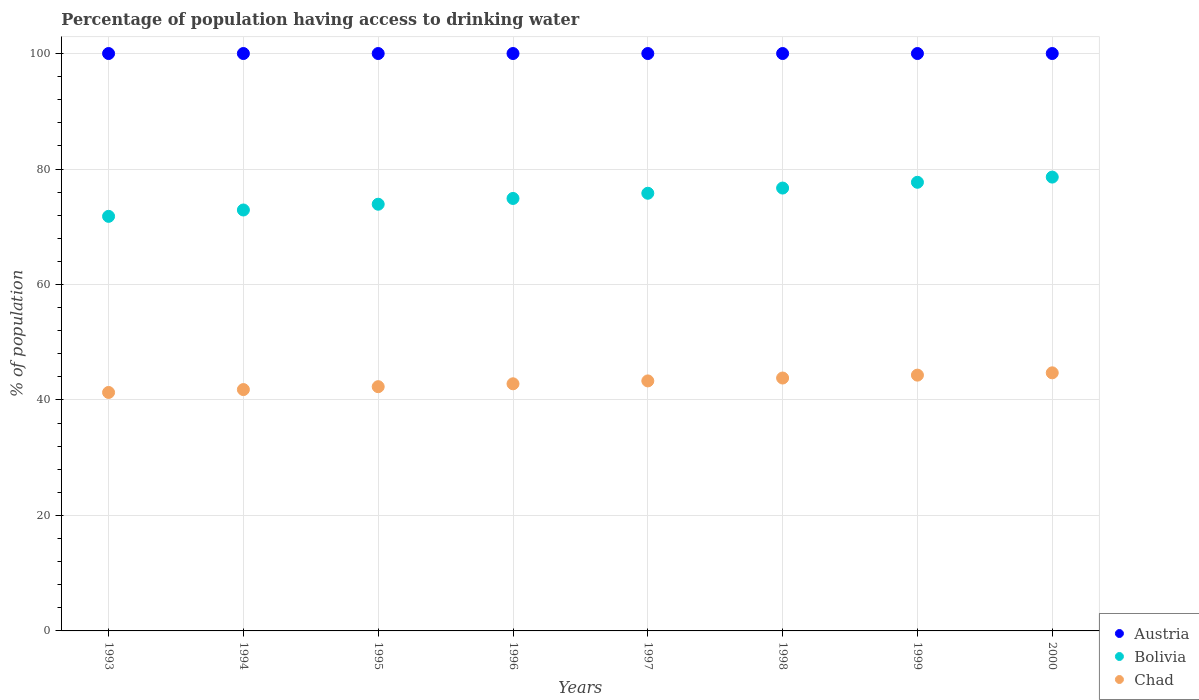How many different coloured dotlines are there?
Ensure brevity in your answer.  3. Is the number of dotlines equal to the number of legend labels?
Offer a very short reply. Yes. What is the percentage of population having access to drinking water in Chad in 1997?
Provide a succinct answer. 43.3. Across all years, what is the maximum percentage of population having access to drinking water in Austria?
Offer a very short reply. 100. Across all years, what is the minimum percentage of population having access to drinking water in Austria?
Make the answer very short. 100. What is the total percentage of population having access to drinking water in Austria in the graph?
Provide a succinct answer. 800. What is the difference between the percentage of population having access to drinking water in Chad in 1997 and that in 2000?
Your answer should be compact. -1.4. What is the difference between the percentage of population having access to drinking water in Bolivia in 1999 and the percentage of population having access to drinking water in Chad in 1996?
Your answer should be very brief. 34.9. What is the average percentage of population having access to drinking water in Bolivia per year?
Your answer should be very brief. 75.29. In the year 1998, what is the difference between the percentage of population having access to drinking water in Austria and percentage of population having access to drinking water in Chad?
Provide a succinct answer. 56.2. In how many years, is the percentage of population having access to drinking water in Chad greater than 96 %?
Keep it short and to the point. 0. What is the ratio of the percentage of population having access to drinking water in Austria in 1995 to that in 1998?
Your response must be concise. 1. What is the difference between the highest and the second highest percentage of population having access to drinking water in Austria?
Ensure brevity in your answer.  0. What is the difference between the highest and the lowest percentage of population having access to drinking water in Bolivia?
Provide a succinct answer. 6.8. In how many years, is the percentage of population having access to drinking water in Austria greater than the average percentage of population having access to drinking water in Austria taken over all years?
Make the answer very short. 0. Is it the case that in every year, the sum of the percentage of population having access to drinking water in Austria and percentage of population having access to drinking water in Chad  is greater than the percentage of population having access to drinking water in Bolivia?
Your answer should be very brief. Yes. Does the percentage of population having access to drinking water in Bolivia monotonically increase over the years?
Offer a terse response. Yes. Is the percentage of population having access to drinking water in Chad strictly less than the percentage of population having access to drinking water in Austria over the years?
Your answer should be very brief. Yes. Are the values on the major ticks of Y-axis written in scientific E-notation?
Offer a terse response. No. Does the graph contain any zero values?
Your answer should be very brief. No. Does the graph contain grids?
Give a very brief answer. Yes. Where does the legend appear in the graph?
Your response must be concise. Bottom right. What is the title of the graph?
Offer a very short reply. Percentage of population having access to drinking water. What is the label or title of the X-axis?
Ensure brevity in your answer.  Years. What is the label or title of the Y-axis?
Give a very brief answer. % of population. What is the % of population of Bolivia in 1993?
Offer a very short reply. 71.8. What is the % of population of Chad in 1993?
Offer a very short reply. 41.3. What is the % of population in Bolivia in 1994?
Ensure brevity in your answer.  72.9. What is the % of population in Chad in 1994?
Provide a succinct answer. 41.8. What is the % of population in Austria in 1995?
Your response must be concise. 100. What is the % of population in Bolivia in 1995?
Ensure brevity in your answer.  73.9. What is the % of population in Chad in 1995?
Your answer should be compact. 42.3. What is the % of population of Austria in 1996?
Keep it short and to the point. 100. What is the % of population of Bolivia in 1996?
Your response must be concise. 74.9. What is the % of population of Chad in 1996?
Keep it short and to the point. 42.8. What is the % of population of Austria in 1997?
Provide a succinct answer. 100. What is the % of population of Bolivia in 1997?
Provide a short and direct response. 75.8. What is the % of population in Chad in 1997?
Your answer should be very brief. 43.3. What is the % of population of Austria in 1998?
Make the answer very short. 100. What is the % of population of Bolivia in 1998?
Offer a very short reply. 76.7. What is the % of population of Chad in 1998?
Keep it short and to the point. 43.8. What is the % of population in Bolivia in 1999?
Keep it short and to the point. 77.7. What is the % of population in Chad in 1999?
Offer a very short reply. 44.3. What is the % of population in Bolivia in 2000?
Ensure brevity in your answer.  78.6. What is the % of population in Chad in 2000?
Provide a succinct answer. 44.7. Across all years, what is the maximum % of population in Austria?
Your answer should be compact. 100. Across all years, what is the maximum % of population of Bolivia?
Provide a short and direct response. 78.6. Across all years, what is the maximum % of population of Chad?
Provide a short and direct response. 44.7. Across all years, what is the minimum % of population of Bolivia?
Your response must be concise. 71.8. Across all years, what is the minimum % of population in Chad?
Provide a short and direct response. 41.3. What is the total % of population in Austria in the graph?
Provide a short and direct response. 800. What is the total % of population in Bolivia in the graph?
Ensure brevity in your answer.  602.3. What is the total % of population in Chad in the graph?
Provide a succinct answer. 344.3. What is the difference between the % of population of Bolivia in 1993 and that in 1994?
Ensure brevity in your answer.  -1.1. What is the difference between the % of population of Chad in 1993 and that in 1994?
Keep it short and to the point. -0.5. What is the difference between the % of population in Chad in 1993 and that in 1995?
Keep it short and to the point. -1. What is the difference between the % of population in Austria in 1993 and that in 1996?
Keep it short and to the point. 0. What is the difference between the % of population of Bolivia in 1993 and that in 1996?
Provide a short and direct response. -3.1. What is the difference between the % of population in Chad in 1993 and that in 1996?
Offer a very short reply. -1.5. What is the difference between the % of population in Chad in 1993 and that in 1997?
Make the answer very short. -2. What is the difference between the % of population in Austria in 1993 and that in 1999?
Offer a terse response. 0. What is the difference between the % of population in Bolivia in 1993 and that in 1999?
Your answer should be compact. -5.9. What is the difference between the % of population of Austria in 1993 and that in 2000?
Ensure brevity in your answer.  0. What is the difference between the % of population of Bolivia in 1993 and that in 2000?
Ensure brevity in your answer.  -6.8. What is the difference between the % of population in Chad in 1993 and that in 2000?
Provide a short and direct response. -3.4. What is the difference between the % of population of Austria in 1994 and that in 1995?
Your response must be concise. 0. What is the difference between the % of population of Bolivia in 1994 and that in 1995?
Ensure brevity in your answer.  -1. What is the difference between the % of population in Chad in 1994 and that in 1995?
Your response must be concise. -0.5. What is the difference between the % of population in Austria in 1994 and that in 1996?
Your answer should be compact. 0. What is the difference between the % of population in Chad in 1994 and that in 1996?
Ensure brevity in your answer.  -1. What is the difference between the % of population of Bolivia in 1994 and that in 1997?
Offer a terse response. -2.9. What is the difference between the % of population in Austria in 1994 and that in 1998?
Offer a terse response. 0. What is the difference between the % of population in Bolivia in 1994 and that in 1998?
Give a very brief answer. -3.8. What is the difference between the % of population in Chad in 1994 and that in 1998?
Your answer should be very brief. -2. What is the difference between the % of population of Austria in 1994 and that in 1999?
Your answer should be compact. 0. What is the difference between the % of population in Chad in 1994 and that in 1999?
Your response must be concise. -2.5. What is the difference between the % of population of Austria in 1994 and that in 2000?
Provide a short and direct response. 0. What is the difference between the % of population in Chad in 1995 and that in 1997?
Your response must be concise. -1. What is the difference between the % of population of Austria in 1995 and that in 1998?
Ensure brevity in your answer.  0. What is the difference between the % of population in Bolivia in 1995 and that in 1998?
Keep it short and to the point. -2.8. What is the difference between the % of population in Austria in 1995 and that in 1999?
Offer a very short reply. 0. What is the difference between the % of population in Bolivia in 1995 and that in 1999?
Ensure brevity in your answer.  -3.8. What is the difference between the % of population of Chad in 1995 and that in 1999?
Provide a succinct answer. -2. What is the difference between the % of population of Bolivia in 1995 and that in 2000?
Your answer should be compact. -4.7. What is the difference between the % of population in Chad in 1996 and that in 1997?
Your answer should be compact. -0.5. What is the difference between the % of population of Austria in 1996 and that in 1998?
Your answer should be compact. 0. What is the difference between the % of population in Bolivia in 1996 and that in 1998?
Give a very brief answer. -1.8. What is the difference between the % of population in Bolivia in 1996 and that in 2000?
Give a very brief answer. -3.7. What is the difference between the % of population of Chad in 1996 and that in 2000?
Offer a terse response. -1.9. What is the difference between the % of population in Bolivia in 1997 and that in 1998?
Keep it short and to the point. -0.9. What is the difference between the % of population of Chad in 1997 and that in 1998?
Make the answer very short. -0.5. What is the difference between the % of population in Bolivia in 1997 and that in 1999?
Make the answer very short. -1.9. What is the difference between the % of population of Bolivia in 1997 and that in 2000?
Make the answer very short. -2.8. What is the difference between the % of population of Chad in 1997 and that in 2000?
Make the answer very short. -1.4. What is the difference between the % of population of Austria in 1998 and that in 1999?
Ensure brevity in your answer.  0. What is the difference between the % of population in Bolivia in 1998 and that in 1999?
Give a very brief answer. -1. What is the difference between the % of population in Chad in 1998 and that in 1999?
Offer a very short reply. -0.5. What is the difference between the % of population in Chad in 1998 and that in 2000?
Your answer should be very brief. -0.9. What is the difference between the % of population of Austria in 1999 and that in 2000?
Your answer should be compact. 0. What is the difference between the % of population in Bolivia in 1999 and that in 2000?
Ensure brevity in your answer.  -0.9. What is the difference between the % of population of Chad in 1999 and that in 2000?
Provide a short and direct response. -0.4. What is the difference between the % of population in Austria in 1993 and the % of population in Bolivia in 1994?
Keep it short and to the point. 27.1. What is the difference between the % of population in Austria in 1993 and the % of population in Chad in 1994?
Make the answer very short. 58.2. What is the difference between the % of population in Austria in 1993 and the % of population in Bolivia in 1995?
Provide a succinct answer. 26.1. What is the difference between the % of population in Austria in 1993 and the % of population in Chad in 1995?
Make the answer very short. 57.7. What is the difference between the % of population of Bolivia in 1993 and the % of population of Chad in 1995?
Your answer should be very brief. 29.5. What is the difference between the % of population in Austria in 1993 and the % of population in Bolivia in 1996?
Your response must be concise. 25.1. What is the difference between the % of population in Austria in 1993 and the % of population in Chad in 1996?
Provide a succinct answer. 57.2. What is the difference between the % of population in Bolivia in 1993 and the % of population in Chad in 1996?
Provide a short and direct response. 29. What is the difference between the % of population of Austria in 1993 and the % of population of Bolivia in 1997?
Give a very brief answer. 24.2. What is the difference between the % of population in Austria in 1993 and the % of population in Chad in 1997?
Provide a succinct answer. 56.7. What is the difference between the % of population in Austria in 1993 and the % of population in Bolivia in 1998?
Make the answer very short. 23.3. What is the difference between the % of population of Austria in 1993 and the % of population of Chad in 1998?
Give a very brief answer. 56.2. What is the difference between the % of population of Bolivia in 1993 and the % of population of Chad in 1998?
Your response must be concise. 28. What is the difference between the % of population of Austria in 1993 and the % of population of Bolivia in 1999?
Make the answer very short. 22.3. What is the difference between the % of population in Austria in 1993 and the % of population in Chad in 1999?
Your answer should be compact. 55.7. What is the difference between the % of population in Bolivia in 1993 and the % of population in Chad in 1999?
Your response must be concise. 27.5. What is the difference between the % of population in Austria in 1993 and the % of population in Bolivia in 2000?
Keep it short and to the point. 21.4. What is the difference between the % of population of Austria in 1993 and the % of population of Chad in 2000?
Your answer should be very brief. 55.3. What is the difference between the % of population in Bolivia in 1993 and the % of population in Chad in 2000?
Offer a terse response. 27.1. What is the difference between the % of population of Austria in 1994 and the % of population of Bolivia in 1995?
Provide a succinct answer. 26.1. What is the difference between the % of population of Austria in 1994 and the % of population of Chad in 1995?
Give a very brief answer. 57.7. What is the difference between the % of population of Bolivia in 1994 and the % of population of Chad in 1995?
Keep it short and to the point. 30.6. What is the difference between the % of population of Austria in 1994 and the % of population of Bolivia in 1996?
Provide a short and direct response. 25.1. What is the difference between the % of population of Austria in 1994 and the % of population of Chad in 1996?
Keep it short and to the point. 57.2. What is the difference between the % of population of Bolivia in 1994 and the % of population of Chad in 1996?
Provide a succinct answer. 30.1. What is the difference between the % of population of Austria in 1994 and the % of population of Bolivia in 1997?
Ensure brevity in your answer.  24.2. What is the difference between the % of population in Austria in 1994 and the % of population in Chad in 1997?
Ensure brevity in your answer.  56.7. What is the difference between the % of population of Bolivia in 1994 and the % of population of Chad in 1997?
Offer a very short reply. 29.6. What is the difference between the % of population of Austria in 1994 and the % of population of Bolivia in 1998?
Ensure brevity in your answer.  23.3. What is the difference between the % of population of Austria in 1994 and the % of population of Chad in 1998?
Make the answer very short. 56.2. What is the difference between the % of population of Bolivia in 1994 and the % of population of Chad in 1998?
Ensure brevity in your answer.  29.1. What is the difference between the % of population in Austria in 1994 and the % of population in Bolivia in 1999?
Your response must be concise. 22.3. What is the difference between the % of population in Austria in 1994 and the % of population in Chad in 1999?
Your response must be concise. 55.7. What is the difference between the % of population of Bolivia in 1994 and the % of population of Chad in 1999?
Offer a very short reply. 28.6. What is the difference between the % of population of Austria in 1994 and the % of population of Bolivia in 2000?
Your response must be concise. 21.4. What is the difference between the % of population of Austria in 1994 and the % of population of Chad in 2000?
Your response must be concise. 55.3. What is the difference between the % of population in Bolivia in 1994 and the % of population in Chad in 2000?
Your answer should be very brief. 28.2. What is the difference between the % of population of Austria in 1995 and the % of population of Bolivia in 1996?
Offer a very short reply. 25.1. What is the difference between the % of population of Austria in 1995 and the % of population of Chad in 1996?
Your answer should be very brief. 57.2. What is the difference between the % of population in Bolivia in 1995 and the % of population in Chad in 1996?
Your answer should be compact. 31.1. What is the difference between the % of population in Austria in 1995 and the % of population in Bolivia in 1997?
Offer a terse response. 24.2. What is the difference between the % of population in Austria in 1995 and the % of population in Chad in 1997?
Your response must be concise. 56.7. What is the difference between the % of population of Bolivia in 1995 and the % of population of Chad in 1997?
Keep it short and to the point. 30.6. What is the difference between the % of population in Austria in 1995 and the % of population in Bolivia in 1998?
Your answer should be compact. 23.3. What is the difference between the % of population of Austria in 1995 and the % of population of Chad in 1998?
Ensure brevity in your answer.  56.2. What is the difference between the % of population of Bolivia in 1995 and the % of population of Chad in 1998?
Your answer should be compact. 30.1. What is the difference between the % of population of Austria in 1995 and the % of population of Bolivia in 1999?
Offer a very short reply. 22.3. What is the difference between the % of population in Austria in 1995 and the % of population in Chad in 1999?
Keep it short and to the point. 55.7. What is the difference between the % of population in Bolivia in 1995 and the % of population in Chad in 1999?
Ensure brevity in your answer.  29.6. What is the difference between the % of population of Austria in 1995 and the % of population of Bolivia in 2000?
Keep it short and to the point. 21.4. What is the difference between the % of population of Austria in 1995 and the % of population of Chad in 2000?
Your answer should be compact. 55.3. What is the difference between the % of population of Bolivia in 1995 and the % of population of Chad in 2000?
Your answer should be very brief. 29.2. What is the difference between the % of population of Austria in 1996 and the % of population of Bolivia in 1997?
Offer a very short reply. 24.2. What is the difference between the % of population in Austria in 1996 and the % of population in Chad in 1997?
Give a very brief answer. 56.7. What is the difference between the % of population of Bolivia in 1996 and the % of population of Chad in 1997?
Offer a terse response. 31.6. What is the difference between the % of population in Austria in 1996 and the % of population in Bolivia in 1998?
Give a very brief answer. 23.3. What is the difference between the % of population of Austria in 1996 and the % of population of Chad in 1998?
Make the answer very short. 56.2. What is the difference between the % of population of Bolivia in 1996 and the % of population of Chad in 1998?
Keep it short and to the point. 31.1. What is the difference between the % of population of Austria in 1996 and the % of population of Bolivia in 1999?
Your answer should be compact. 22.3. What is the difference between the % of population in Austria in 1996 and the % of population in Chad in 1999?
Keep it short and to the point. 55.7. What is the difference between the % of population of Bolivia in 1996 and the % of population of Chad in 1999?
Offer a terse response. 30.6. What is the difference between the % of population of Austria in 1996 and the % of population of Bolivia in 2000?
Your answer should be compact. 21.4. What is the difference between the % of population of Austria in 1996 and the % of population of Chad in 2000?
Ensure brevity in your answer.  55.3. What is the difference between the % of population in Bolivia in 1996 and the % of population in Chad in 2000?
Make the answer very short. 30.2. What is the difference between the % of population in Austria in 1997 and the % of population in Bolivia in 1998?
Keep it short and to the point. 23.3. What is the difference between the % of population of Austria in 1997 and the % of population of Chad in 1998?
Offer a terse response. 56.2. What is the difference between the % of population of Bolivia in 1997 and the % of population of Chad in 1998?
Your response must be concise. 32. What is the difference between the % of population of Austria in 1997 and the % of population of Bolivia in 1999?
Ensure brevity in your answer.  22.3. What is the difference between the % of population in Austria in 1997 and the % of population in Chad in 1999?
Offer a very short reply. 55.7. What is the difference between the % of population of Bolivia in 1997 and the % of population of Chad in 1999?
Offer a terse response. 31.5. What is the difference between the % of population of Austria in 1997 and the % of population of Bolivia in 2000?
Your response must be concise. 21.4. What is the difference between the % of population in Austria in 1997 and the % of population in Chad in 2000?
Offer a terse response. 55.3. What is the difference between the % of population of Bolivia in 1997 and the % of population of Chad in 2000?
Make the answer very short. 31.1. What is the difference between the % of population in Austria in 1998 and the % of population in Bolivia in 1999?
Ensure brevity in your answer.  22.3. What is the difference between the % of population in Austria in 1998 and the % of population in Chad in 1999?
Offer a terse response. 55.7. What is the difference between the % of population in Bolivia in 1998 and the % of population in Chad in 1999?
Your response must be concise. 32.4. What is the difference between the % of population in Austria in 1998 and the % of population in Bolivia in 2000?
Offer a very short reply. 21.4. What is the difference between the % of population of Austria in 1998 and the % of population of Chad in 2000?
Give a very brief answer. 55.3. What is the difference between the % of population of Austria in 1999 and the % of population of Bolivia in 2000?
Offer a terse response. 21.4. What is the difference between the % of population of Austria in 1999 and the % of population of Chad in 2000?
Keep it short and to the point. 55.3. What is the difference between the % of population of Bolivia in 1999 and the % of population of Chad in 2000?
Provide a succinct answer. 33. What is the average % of population of Austria per year?
Give a very brief answer. 100. What is the average % of population in Bolivia per year?
Your response must be concise. 75.29. What is the average % of population of Chad per year?
Offer a very short reply. 43.04. In the year 1993, what is the difference between the % of population of Austria and % of population of Bolivia?
Provide a succinct answer. 28.2. In the year 1993, what is the difference between the % of population of Austria and % of population of Chad?
Make the answer very short. 58.7. In the year 1993, what is the difference between the % of population of Bolivia and % of population of Chad?
Your answer should be very brief. 30.5. In the year 1994, what is the difference between the % of population of Austria and % of population of Bolivia?
Give a very brief answer. 27.1. In the year 1994, what is the difference between the % of population of Austria and % of population of Chad?
Provide a short and direct response. 58.2. In the year 1994, what is the difference between the % of population of Bolivia and % of population of Chad?
Provide a succinct answer. 31.1. In the year 1995, what is the difference between the % of population in Austria and % of population in Bolivia?
Keep it short and to the point. 26.1. In the year 1995, what is the difference between the % of population of Austria and % of population of Chad?
Keep it short and to the point. 57.7. In the year 1995, what is the difference between the % of population of Bolivia and % of population of Chad?
Ensure brevity in your answer.  31.6. In the year 1996, what is the difference between the % of population in Austria and % of population in Bolivia?
Offer a very short reply. 25.1. In the year 1996, what is the difference between the % of population in Austria and % of population in Chad?
Ensure brevity in your answer.  57.2. In the year 1996, what is the difference between the % of population in Bolivia and % of population in Chad?
Keep it short and to the point. 32.1. In the year 1997, what is the difference between the % of population of Austria and % of population of Bolivia?
Keep it short and to the point. 24.2. In the year 1997, what is the difference between the % of population in Austria and % of population in Chad?
Keep it short and to the point. 56.7. In the year 1997, what is the difference between the % of population of Bolivia and % of population of Chad?
Ensure brevity in your answer.  32.5. In the year 1998, what is the difference between the % of population in Austria and % of population in Bolivia?
Your answer should be very brief. 23.3. In the year 1998, what is the difference between the % of population in Austria and % of population in Chad?
Your response must be concise. 56.2. In the year 1998, what is the difference between the % of population of Bolivia and % of population of Chad?
Provide a short and direct response. 32.9. In the year 1999, what is the difference between the % of population of Austria and % of population of Bolivia?
Offer a very short reply. 22.3. In the year 1999, what is the difference between the % of population of Austria and % of population of Chad?
Your response must be concise. 55.7. In the year 1999, what is the difference between the % of population in Bolivia and % of population in Chad?
Your answer should be compact. 33.4. In the year 2000, what is the difference between the % of population in Austria and % of population in Bolivia?
Ensure brevity in your answer.  21.4. In the year 2000, what is the difference between the % of population in Austria and % of population in Chad?
Make the answer very short. 55.3. In the year 2000, what is the difference between the % of population in Bolivia and % of population in Chad?
Provide a succinct answer. 33.9. What is the ratio of the % of population of Austria in 1993 to that in 1994?
Your response must be concise. 1. What is the ratio of the % of population of Bolivia in 1993 to that in 1994?
Keep it short and to the point. 0.98. What is the ratio of the % of population in Austria in 1993 to that in 1995?
Offer a terse response. 1. What is the ratio of the % of population in Bolivia in 1993 to that in 1995?
Ensure brevity in your answer.  0.97. What is the ratio of the % of population in Chad in 1993 to that in 1995?
Your answer should be very brief. 0.98. What is the ratio of the % of population of Bolivia in 1993 to that in 1996?
Your answer should be compact. 0.96. What is the ratio of the % of population of Chad in 1993 to that in 1996?
Make the answer very short. 0.96. What is the ratio of the % of population of Bolivia in 1993 to that in 1997?
Make the answer very short. 0.95. What is the ratio of the % of population of Chad in 1993 to that in 1997?
Give a very brief answer. 0.95. What is the ratio of the % of population in Austria in 1993 to that in 1998?
Make the answer very short. 1. What is the ratio of the % of population of Bolivia in 1993 to that in 1998?
Your answer should be very brief. 0.94. What is the ratio of the % of population of Chad in 1993 to that in 1998?
Your answer should be very brief. 0.94. What is the ratio of the % of population of Bolivia in 1993 to that in 1999?
Offer a very short reply. 0.92. What is the ratio of the % of population in Chad in 1993 to that in 1999?
Offer a very short reply. 0.93. What is the ratio of the % of population in Austria in 1993 to that in 2000?
Make the answer very short. 1. What is the ratio of the % of population in Bolivia in 1993 to that in 2000?
Keep it short and to the point. 0.91. What is the ratio of the % of population in Chad in 1993 to that in 2000?
Keep it short and to the point. 0.92. What is the ratio of the % of population in Austria in 1994 to that in 1995?
Your answer should be compact. 1. What is the ratio of the % of population of Bolivia in 1994 to that in 1995?
Offer a very short reply. 0.99. What is the ratio of the % of population of Chad in 1994 to that in 1995?
Your answer should be very brief. 0.99. What is the ratio of the % of population in Austria in 1994 to that in 1996?
Provide a succinct answer. 1. What is the ratio of the % of population of Bolivia in 1994 to that in 1996?
Your answer should be very brief. 0.97. What is the ratio of the % of population of Chad in 1994 to that in 1996?
Give a very brief answer. 0.98. What is the ratio of the % of population of Austria in 1994 to that in 1997?
Give a very brief answer. 1. What is the ratio of the % of population of Bolivia in 1994 to that in 1997?
Keep it short and to the point. 0.96. What is the ratio of the % of population in Chad in 1994 to that in 1997?
Your response must be concise. 0.97. What is the ratio of the % of population in Bolivia in 1994 to that in 1998?
Your response must be concise. 0.95. What is the ratio of the % of population of Chad in 1994 to that in 1998?
Make the answer very short. 0.95. What is the ratio of the % of population of Austria in 1994 to that in 1999?
Give a very brief answer. 1. What is the ratio of the % of population in Bolivia in 1994 to that in 1999?
Provide a short and direct response. 0.94. What is the ratio of the % of population of Chad in 1994 to that in 1999?
Offer a very short reply. 0.94. What is the ratio of the % of population of Austria in 1994 to that in 2000?
Provide a short and direct response. 1. What is the ratio of the % of population in Bolivia in 1994 to that in 2000?
Ensure brevity in your answer.  0.93. What is the ratio of the % of population in Chad in 1994 to that in 2000?
Make the answer very short. 0.94. What is the ratio of the % of population of Austria in 1995 to that in 1996?
Provide a succinct answer. 1. What is the ratio of the % of population of Bolivia in 1995 to that in 1996?
Make the answer very short. 0.99. What is the ratio of the % of population in Chad in 1995 to that in 1996?
Your answer should be very brief. 0.99. What is the ratio of the % of population in Austria in 1995 to that in 1997?
Provide a short and direct response. 1. What is the ratio of the % of population in Bolivia in 1995 to that in 1997?
Your answer should be very brief. 0.97. What is the ratio of the % of population of Chad in 1995 to that in 1997?
Your response must be concise. 0.98. What is the ratio of the % of population in Bolivia in 1995 to that in 1998?
Offer a terse response. 0.96. What is the ratio of the % of population in Chad in 1995 to that in 1998?
Offer a terse response. 0.97. What is the ratio of the % of population of Austria in 1995 to that in 1999?
Keep it short and to the point. 1. What is the ratio of the % of population in Bolivia in 1995 to that in 1999?
Give a very brief answer. 0.95. What is the ratio of the % of population in Chad in 1995 to that in 1999?
Your answer should be very brief. 0.95. What is the ratio of the % of population of Austria in 1995 to that in 2000?
Make the answer very short. 1. What is the ratio of the % of population of Bolivia in 1995 to that in 2000?
Your response must be concise. 0.94. What is the ratio of the % of population of Chad in 1995 to that in 2000?
Give a very brief answer. 0.95. What is the ratio of the % of population of Chad in 1996 to that in 1997?
Provide a short and direct response. 0.99. What is the ratio of the % of population in Bolivia in 1996 to that in 1998?
Make the answer very short. 0.98. What is the ratio of the % of population of Chad in 1996 to that in 1998?
Make the answer very short. 0.98. What is the ratio of the % of population of Austria in 1996 to that in 1999?
Keep it short and to the point. 1. What is the ratio of the % of population of Chad in 1996 to that in 1999?
Your answer should be compact. 0.97. What is the ratio of the % of population in Austria in 1996 to that in 2000?
Make the answer very short. 1. What is the ratio of the % of population of Bolivia in 1996 to that in 2000?
Provide a succinct answer. 0.95. What is the ratio of the % of population of Chad in 1996 to that in 2000?
Make the answer very short. 0.96. What is the ratio of the % of population of Austria in 1997 to that in 1998?
Your response must be concise. 1. What is the ratio of the % of population of Bolivia in 1997 to that in 1998?
Your response must be concise. 0.99. What is the ratio of the % of population of Chad in 1997 to that in 1998?
Your answer should be very brief. 0.99. What is the ratio of the % of population of Bolivia in 1997 to that in 1999?
Ensure brevity in your answer.  0.98. What is the ratio of the % of population of Chad in 1997 to that in 1999?
Provide a succinct answer. 0.98. What is the ratio of the % of population in Bolivia in 1997 to that in 2000?
Make the answer very short. 0.96. What is the ratio of the % of population of Chad in 1997 to that in 2000?
Offer a terse response. 0.97. What is the ratio of the % of population of Bolivia in 1998 to that in 1999?
Your answer should be compact. 0.99. What is the ratio of the % of population of Chad in 1998 to that in 1999?
Your answer should be compact. 0.99. What is the ratio of the % of population in Bolivia in 1998 to that in 2000?
Make the answer very short. 0.98. What is the ratio of the % of population of Chad in 1998 to that in 2000?
Your answer should be very brief. 0.98. What is the ratio of the % of population of Bolivia in 1999 to that in 2000?
Keep it short and to the point. 0.99. What is the ratio of the % of population of Chad in 1999 to that in 2000?
Offer a very short reply. 0.99. What is the difference between the highest and the second highest % of population of Bolivia?
Offer a very short reply. 0.9. What is the difference between the highest and the second highest % of population of Chad?
Keep it short and to the point. 0.4. What is the difference between the highest and the lowest % of population in Chad?
Offer a very short reply. 3.4. 